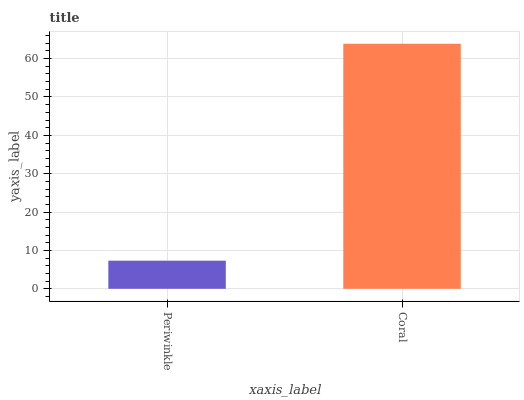Is Periwinkle the minimum?
Answer yes or no. Yes. Is Coral the maximum?
Answer yes or no. Yes. Is Coral the minimum?
Answer yes or no. No. Is Coral greater than Periwinkle?
Answer yes or no. Yes. Is Periwinkle less than Coral?
Answer yes or no. Yes. Is Periwinkle greater than Coral?
Answer yes or no. No. Is Coral less than Periwinkle?
Answer yes or no. No. Is Coral the high median?
Answer yes or no. Yes. Is Periwinkle the low median?
Answer yes or no. Yes. Is Periwinkle the high median?
Answer yes or no. No. Is Coral the low median?
Answer yes or no. No. 